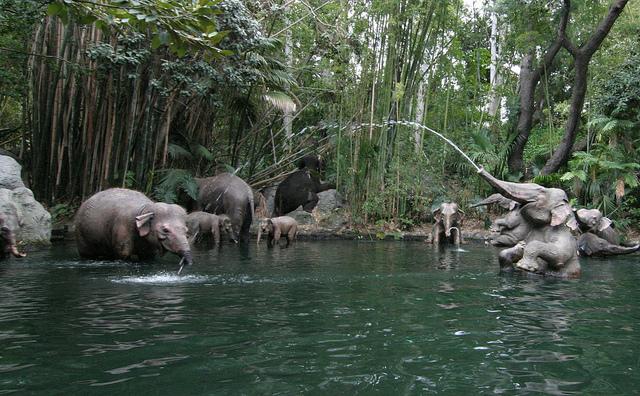What is the front elephant on the right doing with his trunk?
Write a very short answer. Spraying water. Was this picture taken in Antarctica?
Give a very brief answer. No. How many elephants are there?
Short answer required. 9. Are the elephants in the water?
Quick response, please. Yes. 